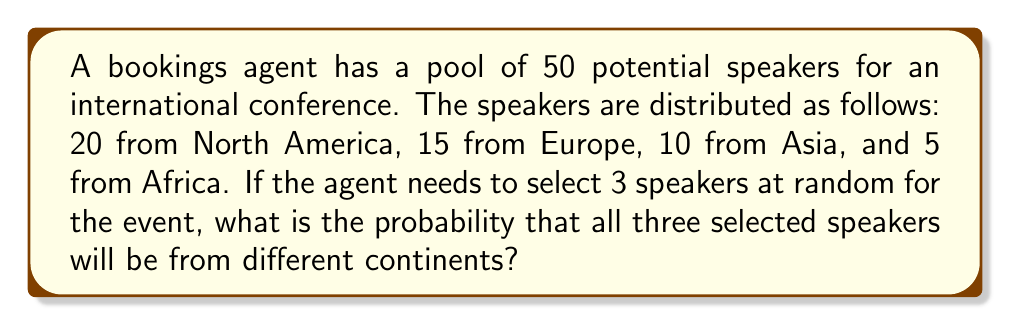Show me your answer to this math problem. Let's approach this step-by-step:

1) First, we need to calculate the total number of ways to select 3 speakers out of 50. This is given by the combination formula:

   $$\binom{50}{3} = \frac{50!}{3!(50-3)!} = \frac{50!}{3!47!} = 19,600$$

2) Now, we need to calculate the number of favorable outcomes (selecting 3 speakers from different continents). We can do this by:
   - Choosing 1 from North America (20 ways)
   - Choosing 1 from Europe (15 ways)
   - Choosing 1 from either Asia or Africa (15 ways)

   We can also choose them in different orders, so we multiply by 3! (6 ways)

   $$20 \times 15 \times 15 \times 6 = 27,000$$

3) The probability is then the number of favorable outcomes divided by the total number of possible outcomes:

   $$P(\text{3 speakers from different continents}) = \frac{27,000}{19,600} = \frac{675}{490} \approx 1.3776$$

4) However, this probability is greater than 1, which is impossible. This is because we've overcounted in step 2. We need to divide by 3! to account for the fact that we've counted each unique combination 6 times:

   $$P(\text{3 speakers from different continents}) = \frac{27,000 \div 6}{19,600} = \frac{4,500}{19,600} = \frac{225}{980} \approx 0.2296$$
Answer: $\frac{225}{980}$ or approximately 0.2296 